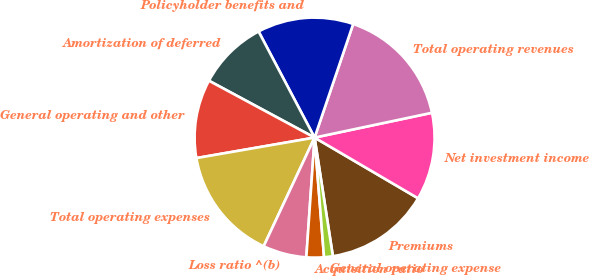Convert chart to OTSL. <chart><loc_0><loc_0><loc_500><loc_500><pie_chart><fcel>Premiums<fcel>Net investment income<fcel>Total operating revenues<fcel>Policyholder benefits and<fcel>Amortization of deferred<fcel>General operating and other<fcel>Total operating expenses<fcel>Loss ratio ^(b)<fcel>Acquisition ratio<fcel>General operating expense<nl><fcel>14.12%<fcel>11.76%<fcel>16.47%<fcel>12.94%<fcel>9.41%<fcel>10.59%<fcel>15.29%<fcel>5.88%<fcel>2.35%<fcel>1.18%<nl></chart> 